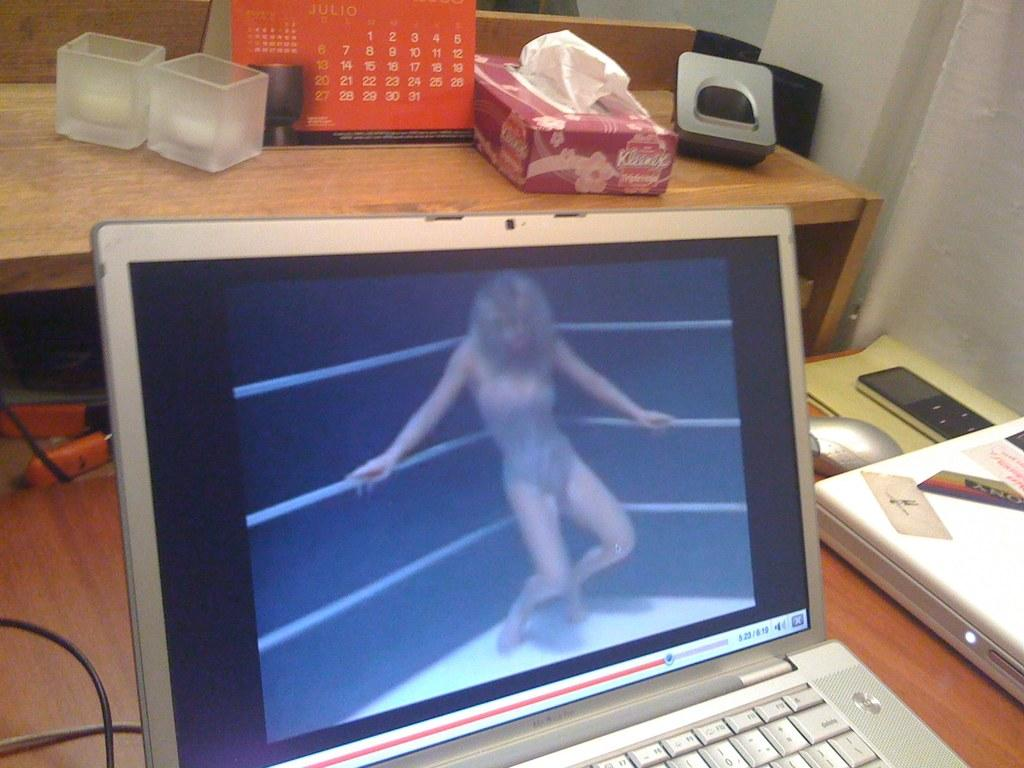What electronic device is present in the image? There is a laptop in the image. What can be seen on the laptop screen? A woman is visible on the laptop screen. What else is on the table behind the laptop? There are objects on the table behind the laptop. What can be seen in the top right corner of the image? There is a wall visible in the top right corner of the image. What type of cub is visible in the image? There is no cub present in the image. How does the porter assist the woman on the laptop screen? There is no porter present in the image, and the woman on the laptop screen is not interacting with anyone. 